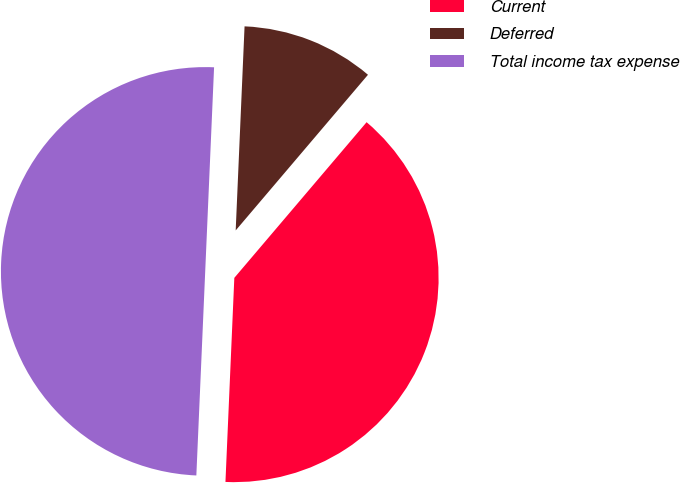Convert chart. <chart><loc_0><loc_0><loc_500><loc_500><pie_chart><fcel>Current<fcel>Deferred<fcel>Total income tax expense<nl><fcel>39.48%<fcel>10.52%<fcel>50.0%<nl></chart> 